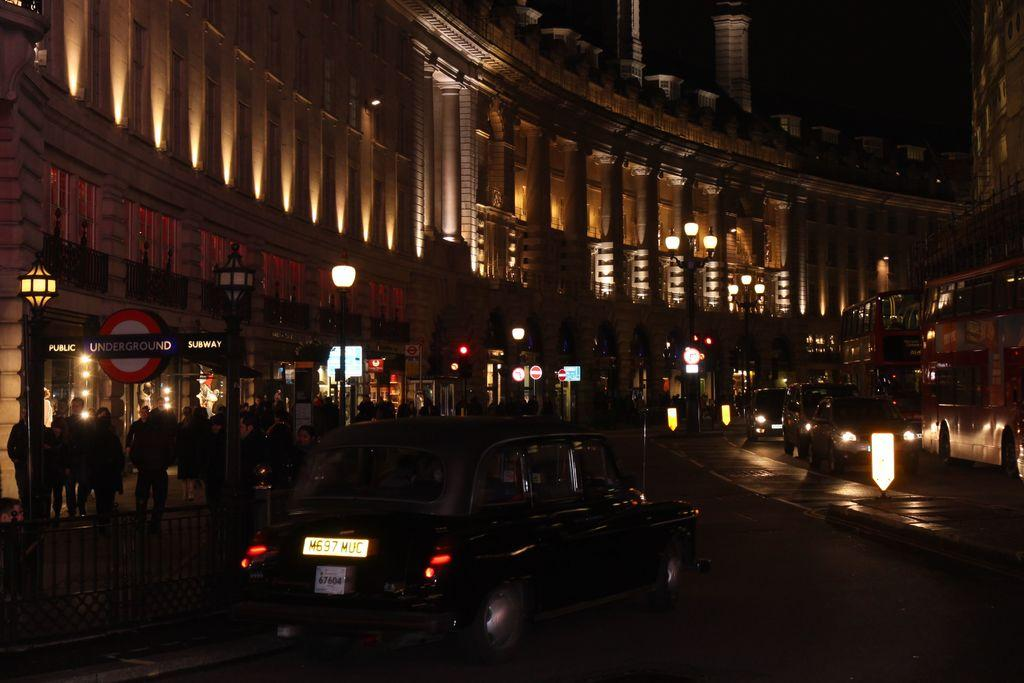What is the overall lighting condition in the image? The image is dark. What can be seen on the road in the image? There are vehicles on the road in the image. What is present along the side of the road? There is a fence in the image. Can you describe the people in the image? There are people in the image. What can be seen in the distance in the image? In the background, there are lights visible, as well as boards on poles and buildings. Can you tell me how many monkeys are sitting on the fence in the image? There are no monkeys present in the image; it features vehicles on the road, a fence, and people. What type of mist can be seen covering the buildings in the image? There is no mist present in the image; the buildings are visible in the background. 